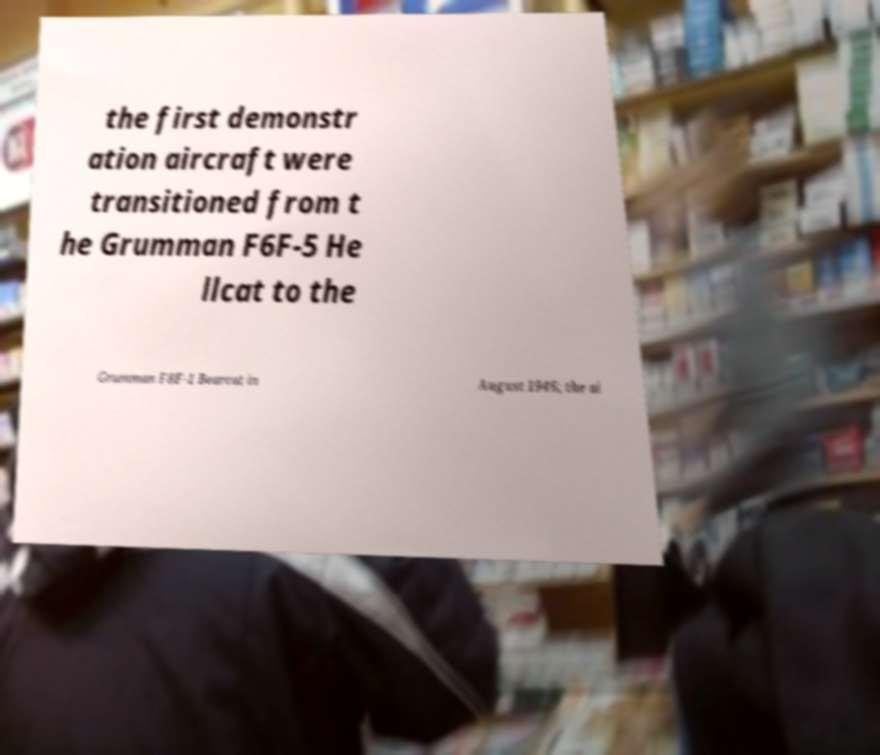Could you extract and type out the text from this image? the first demonstr ation aircraft were transitioned from t he Grumman F6F-5 He llcat to the Grumman F8F-1 Bearcat in August 1946; the ai 